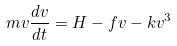Convert formula to latex. <formula><loc_0><loc_0><loc_500><loc_500>m v \frac { d v } { d t } = H - f v - k v ^ { 3 }</formula> 